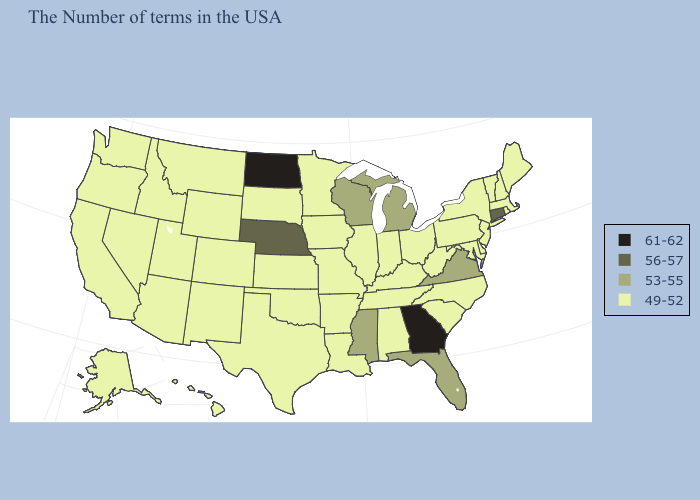Name the states that have a value in the range 56-57?
Be succinct. Connecticut, Nebraska. Which states have the lowest value in the South?
Short answer required. Delaware, Maryland, North Carolina, South Carolina, West Virginia, Kentucky, Alabama, Tennessee, Louisiana, Arkansas, Oklahoma, Texas. Which states hav the highest value in the MidWest?
Short answer required. North Dakota. Does Connecticut have the lowest value in the Northeast?
Keep it brief. No. Which states have the lowest value in the Northeast?
Answer briefly. Maine, Massachusetts, Rhode Island, New Hampshire, Vermont, New York, New Jersey, Pennsylvania. Does North Dakota have a higher value than Georgia?
Keep it brief. No. Does Virginia have the same value as Arkansas?
Write a very short answer. No. Name the states that have a value in the range 53-55?
Concise answer only. Virginia, Florida, Michigan, Wisconsin, Mississippi. Name the states that have a value in the range 53-55?
Give a very brief answer. Virginia, Florida, Michigan, Wisconsin, Mississippi. Name the states that have a value in the range 49-52?
Be succinct. Maine, Massachusetts, Rhode Island, New Hampshire, Vermont, New York, New Jersey, Delaware, Maryland, Pennsylvania, North Carolina, South Carolina, West Virginia, Ohio, Kentucky, Indiana, Alabama, Tennessee, Illinois, Louisiana, Missouri, Arkansas, Minnesota, Iowa, Kansas, Oklahoma, Texas, South Dakota, Wyoming, Colorado, New Mexico, Utah, Montana, Arizona, Idaho, Nevada, California, Washington, Oregon, Alaska, Hawaii. What is the lowest value in states that border Florida?
Keep it brief. 49-52. Name the states that have a value in the range 56-57?
Write a very short answer. Connecticut, Nebraska. What is the highest value in states that border Illinois?
Be succinct. 53-55. Does the map have missing data?
Quick response, please. No. Does Virginia have a lower value than New York?
Short answer required. No. 